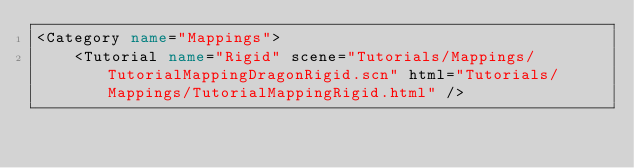<code> <loc_0><loc_0><loc_500><loc_500><_XML_><Category name="Mappings">
    <Tutorial name="Rigid" scene="Tutorials/Mappings/TutorialMappingDragonRigid.scn" html="Tutorials/Mappings/TutorialMappingRigid.html" /></code> 